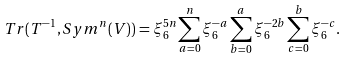<formula> <loc_0><loc_0><loc_500><loc_500>T r ( T ^ { - 1 } , S y m ^ { n } ( V ) ) & = \xi _ { 6 } ^ { 5 n } \sum _ { a = 0 } ^ { n } \xi _ { 6 } ^ { - a } \sum _ { b = 0 } ^ { a } \xi _ { 6 } ^ { - 2 b } \sum _ { c = 0 } ^ { b } \xi _ { 6 } ^ { - c } .</formula> 